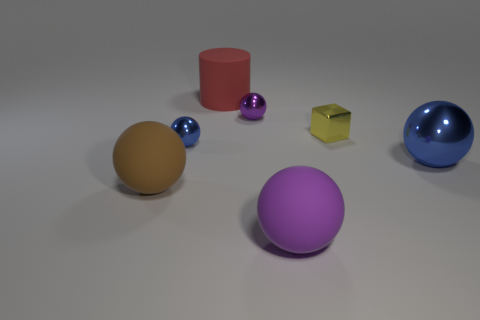Are there any red cylinders that have the same size as the purple shiny ball?
Give a very brief answer. No. There is a purple object that is behind the big blue metallic sphere; are there any small metal things that are behind it?
Offer a very short reply. No. What number of cylinders are either big red matte objects or purple metal things?
Keep it short and to the point. 1. Are there any gray objects of the same shape as the small purple object?
Ensure brevity in your answer.  No. What shape is the large metal thing?
Your answer should be compact. Sphere. How many objects are either large brown matte balls or large blue shiny spheres?
Your answer should be compact. 2. Is the size of the blue object behind the big blue sphere the same as the red rubber object behind the yellow block?
Offer a very short reply. No. What number of other things are there of the same material as the large red cylinder
Provide a short and direct response. 2. Is the number of tiny yellow metal cubes on the right side of the large purple rubber object greater than the number of spheres behind the cylinder?
Make the answer very short. Yes. There is a purple thing that is right of the purple shiny object; what is it made of?
Provide a succinct answer. Rubber. 